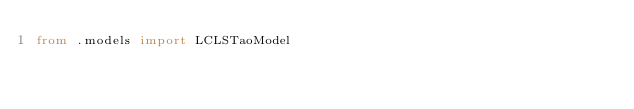Convert code to text. <code><loc_0><loc_0><loc_500><loc_500><_Python_>from .models import LCLSTaoModel</code> 